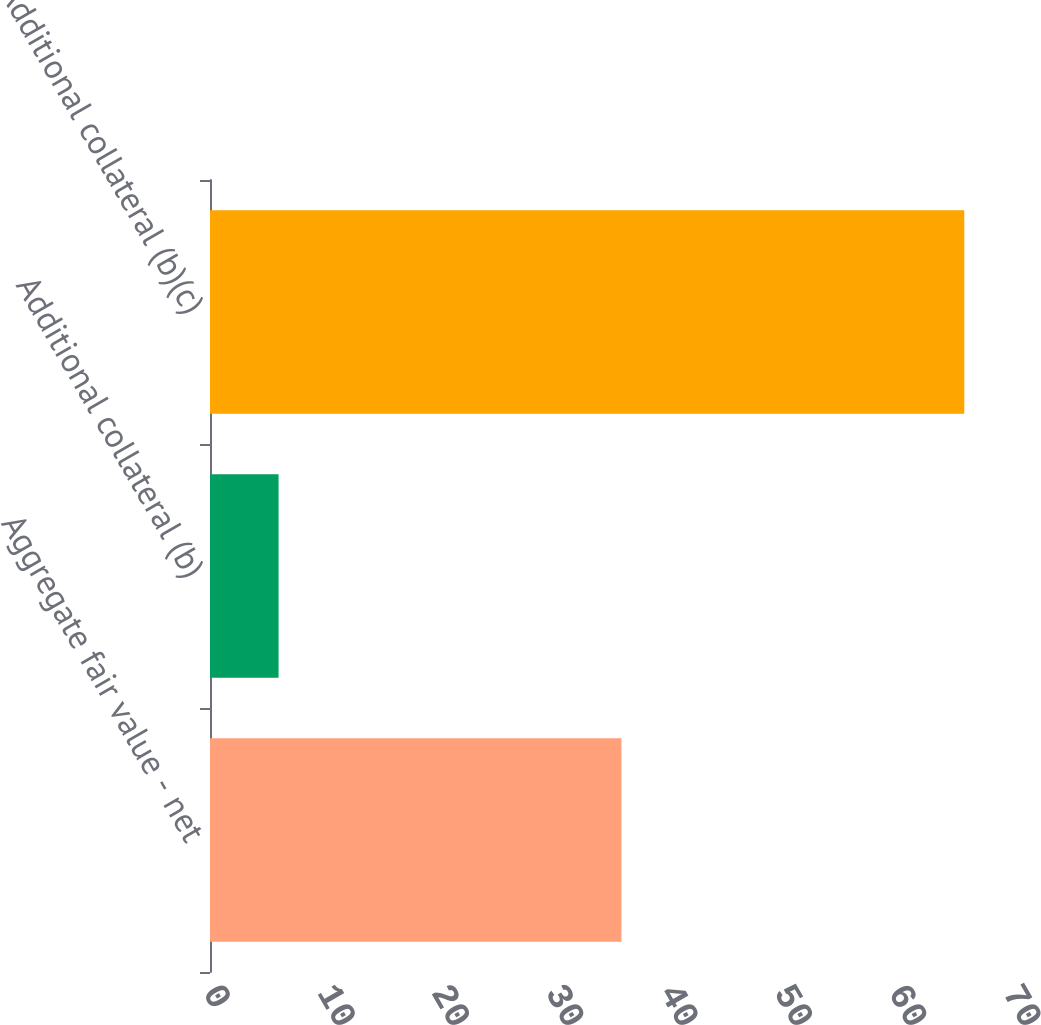Convert chart. <chart><loc_0><loc_0><loc_500><loc_500><bar_chart><fcel>Aggregate fair value - net<fcel>Additional collateral (b)<fcel>Additional collateral (b)(c)<nl><fcel>36<fcel>6<fcel>66<nl></chart> 